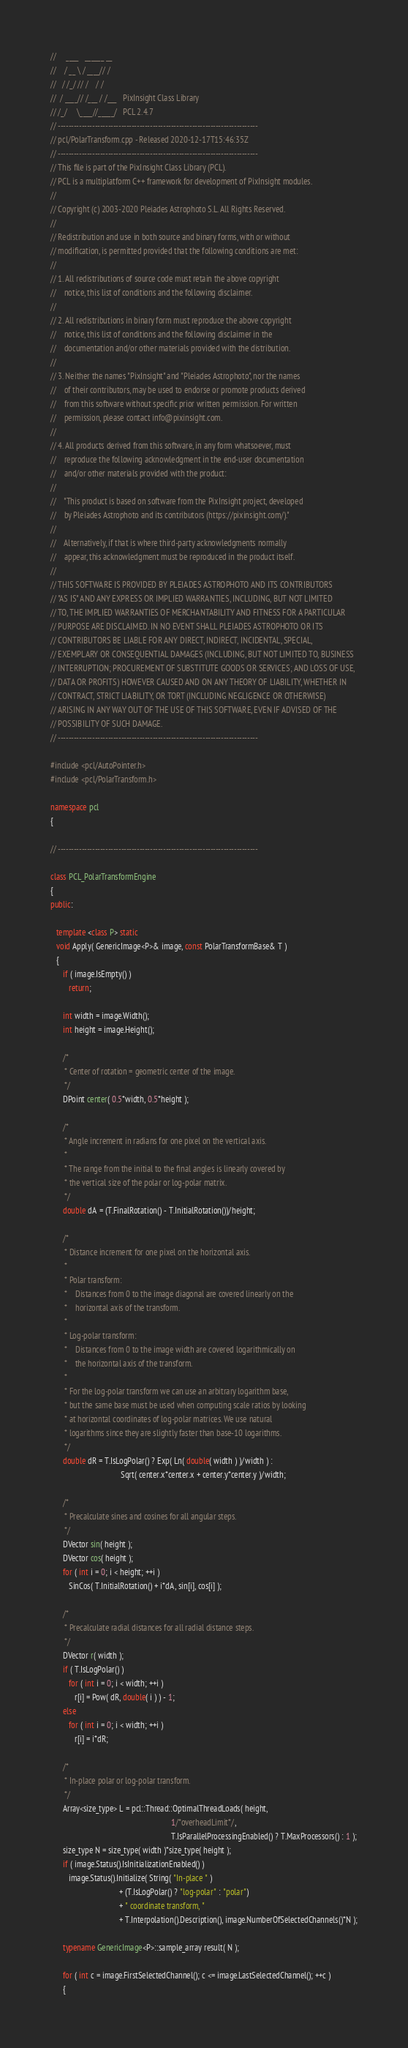<code> <loc_0><loc_0><loc_500><loc_500><_C++_>//     ____   ______ __
//    / __ \ / ____// /
//   / /_/ // /    / /
//  / ____// /___ / /___   PixInsight Class Library
// /_/     \____//_____/   PCL 2.4.7
// ----------------------------------------------------------------------------
// pcl/PolarTransform.cpp - Released 2020-12-17T15:46:35Z
// ----------------------------------------------------------------------------
// This file is part of the PixInsight Class Library (PCL).
// PCL is a multiplatform C++ framework for development of PixInsight modules.
//
// Copyright (c) 2003-2020 Pleiades Astrophoto S.L. All Rights Reserved.
//
// Redistribution and use in both source and binary forms, with or without
// modification, is permitted provided that the following conditions are met:
//
// 1. All redistributions of source code must retain the above copyright
//    notice, this list of conditions and the following disclaimer.
//
// 2. All redistributions in binary form must reproduce the above copyright
//    notice, this list of conditions and the following disclaimer in the
//    documentation and/or other materials provided with the distribution.
//
// 3. Neither the names "PixInsight" and "Pleiades Astrophoto", nor the names
//    of their contributors, may be used to endorse or promote products derived
//    from this software without specific prior written permission. For written
//    permission, please contact info@pixinsight.com.
//
// 4. All products derived from this software, in any form whatsoever, must
//    reproduce the following acknowledgment in the end-user documentation
//    and/or other materials provided with the product:
//
//    "This product is based on software from the PixInsight project, developed
//    by Pleiades Astrophoto and its contributors (https://pixinsight.com/)."
//
//    Alternatively, if that is where third-party acknowledgments normally
//    appear, this acknowledgment must be reproduced in the product itself.
//
// THIS SOFTWARE IS PROVIDED BY PLEIADES ASTROPHOTO AND ITS CONTRIBUTORS
// "AS IS" AND ANY EXPRESS OR IMPLIED WARRANTIES, INCLUDING, BUT NOT LIMITED
// TO, THE IMPLIED WARRANTIES OF MERCHANTABILITY AND FITNESS FOR A PARTICULAR
// PURPOSE ARE DISCLAIMED. IN NO EVENT SHALL PLEIADES ASTROPHOTO OR ITS
// CONTRIBUTORS BE LIABLE FOR ANY DIRECT, INDIRECT, INCIDENTAL, SPECIAL,
// EXEMPLARY OR CONSEQUENTIAL DAMAGES (INCLUDING, BUT NOT LIMITED TO, BUSINESS
// INTERRUPTION; PROCUREMENT OF SUBSTITUTE GOODS OR SERVICES; AND LOSS OF USE,
// DATA OR PROFITS) HOWEVER CAUSED AND ON ANY THEORY OF LIABILITY, WHETHER IN
// CONTRACT, STRICT LIABILITY, OR TORT (INCLUDING NEGLIGENCE OR OTHERWISE)
// ARISING IN ANY WAY OUT OF THE USE OF THIS SOFTWARE, EVEN IF ADVISED OF THE
// POSSIBILITY OF SUCH DAMAGE.
// ----------------------------------------------------------------------------

#include <pcl/AutoPointer.h>
#include <pcl/PolarTransform.h>

namespace pcl
{

// ----------------------------------------------------------------------------

class PCL_PolarTransformEngine
{
public:

   template <class P> static
   void Apply( GenericImage<P>& image, const PolarTransformBase& T )
   {
      if ( image.IsEmpty() )
         return;

      int width = image.Width();
      int height = image.Height();

      /*
       * Center of rotation = geometric center of the image.
       */
      DPoint center( 0.5*width, 0.5*height );

      /*
       * Angle increment in radians for one pixel on the vertical axis.
       *
       * The range from the initial to the final angles is linearly covered by
       * the vertical size of the polar or log-polar matrix.
       */
      double dA = (T.FinalRotation() - T.InitialRotation())/height;

      /*
       * Distance increment for one pixel on the horizontal axis.
       *
       * Polar transform:
       *    Distances from 0 to the image diagonal are covered linearly on the
       *    horizontal axis of the transform.
       *
       * Log-polar transform:
       *    Distances from 0 to the image width are covered logarithmically on
       *    the horizontal axis of the transform.
       *
       * For the log-polar transform we can use an arbitrary logarithm base,
       * but the same base must be used when computing scale ratios by looking
       * at horizontal coordinates of log-polar matrices. We use natural
       * logarithms since they are slightly faster than base-10 logarithms.
       */
      double dR = T.IsLogPolar() ? Exp( Ln( double( width ) )/width ) :
                                   Sqrt( center.x*center.x + center.y*center.y )/width;

      /*
       * Precalculate sines and cosines for all angular steps.
       */
      DVector sin( height );
      DVector cos( height );
      for ( int i = 0; i < height; ++i )
         SinCos( T.InitialRotation() + i*dA, sin[i], cos[i] );

      /*
       * Precalculate radial distances for all radial distance steps.
       */
      DVector r( width );
      if ( T.IsLogPolar() )
         for ( int i = 0; i < width; ++i )
            r[i] = Pow( dR, double( i ) ) - 1;
      else
         for ( int i = 0; i < width; ++i )
            r[i] = i*dR;

      /*
       * In-place polar or log-polar transform.
       */
      Array<size_type> L = pcl::Thread::OptimalThreadLoads( height,
                                                            1/*overheadLimit*/,
                                                            T.IsParallelProcessingEnabled() ? T.MaxProcessors() : 1 );
      size_type N = size_type( width )*size_type( height );
      if ( image.Status().IsInitializationEnabled() )
         image.Status().Initialize( String( "In-place " )
                                  + (T.IsLogPolar() ? "log-polar" : "polar")
                                  + " coordinate transform, "
                                  + T.Interpolation().Description(), image.NumberOfSelectedChannels()*N );

      typename GenericImage<P>::sample_array result( N );

      for ( int c = image.FirstSelectedChannel(); c <= image.LastSelectedChannel(); ++c )
      {</code> 